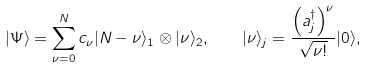Convert formula to latex. <formula><loc_0><loc_0><loc_500><loc_500>| \Psi \rangle = \sum _ { \nu = 0 } ^ { N } c _ { \nu } | N - \nu \rangle _ { 1 } \otimes | \nu \rangle _ { 2 } , \quad | \nu \rangle _ { j } = \frac { \left ( a _ { j } ^ { \dag } \right ) ^ { \nu } } { \sqrt { \nu ! } } | 0 \rangle ,</formula> 